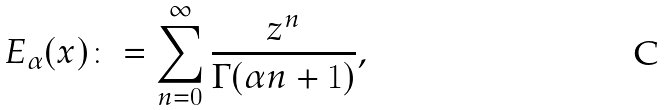Convert formula to latex. <formula><loc_0><loc_0><loc_500><loc_500>E _ { \alpha } ( x ) \colon = \sum ^ { \infty } _ { n = 0 } \frac { z ^ { n } } { \Gamma ( \alpha n + 1 ) } ,</formula> 